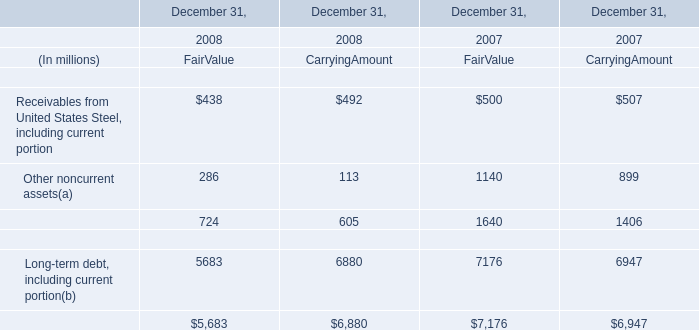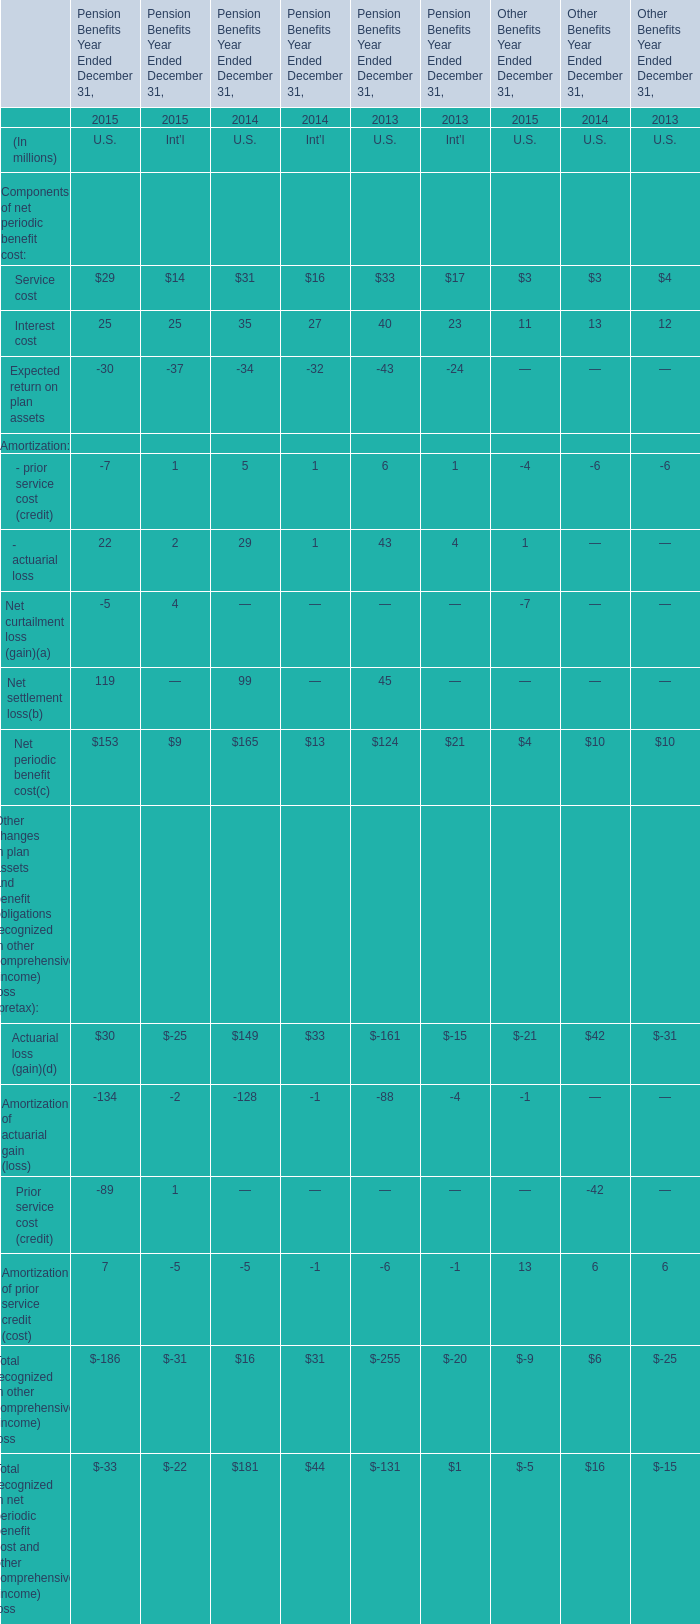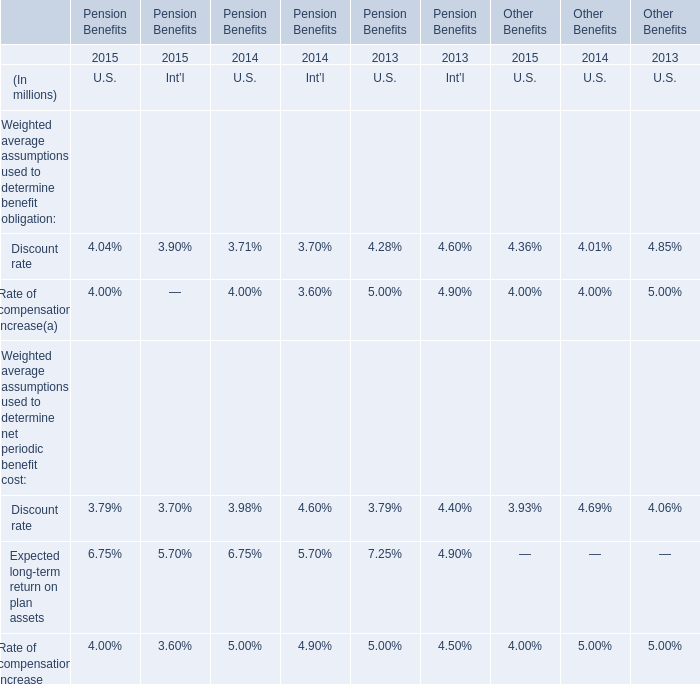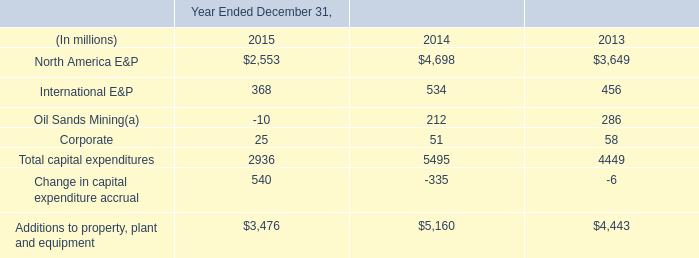In the year with largest amount of Interest cost what's the increasing rate of - actuarial loss for Pension Benefits Year Ended December 31,? 
Computations: ((((29 + 1) - 43) - 4) / (43 + 4))
Answer: -0.3617. 